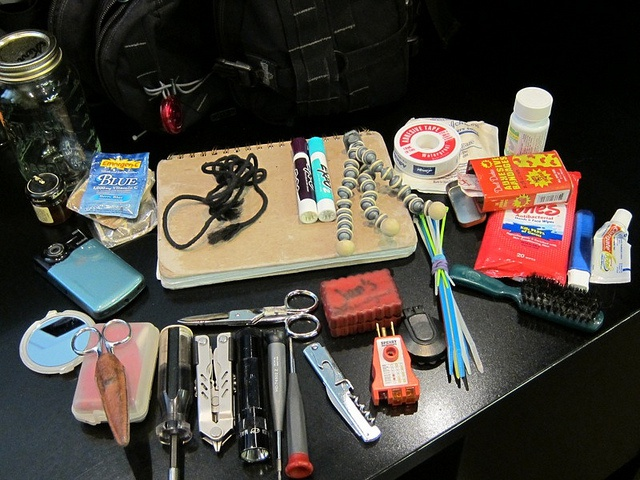Describe the objects in this image and their specific colors. I can see book in gray, tan, and black tones, backpack in gray and black tones, bottle in gray, black, darkgreen, and darkgray tones, cell phone in gray, lightblue, and black tones, and scissors in gray, brown, lightpink, darkgray, and lightblue tones in this image. 